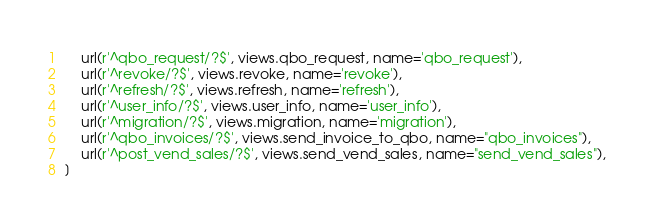<code> <loc_0><loc_0><loc_500><loc_500><_Python_>    url(r'^qbo_request/?$', views.qbo_request, name='qbo_request'),
    url(r'^revoke/?$', views.revoke, name='revoke'),
    url(r'^refresh/?$', views.refresh, name='refresh'),
    url(r'^user_info/?$', views.user_info, name='user_info'),
    url(r'^migration/?$', views.migration, name='migration'),
    url(r'^qbo_invoices/?$', views.send_invoice_to_qbo, name="qbo_invoices"),
    url(r'^post_vend_sales/?$', views.send_vend_sales, name="send_vend_sales"),
]
</code> 